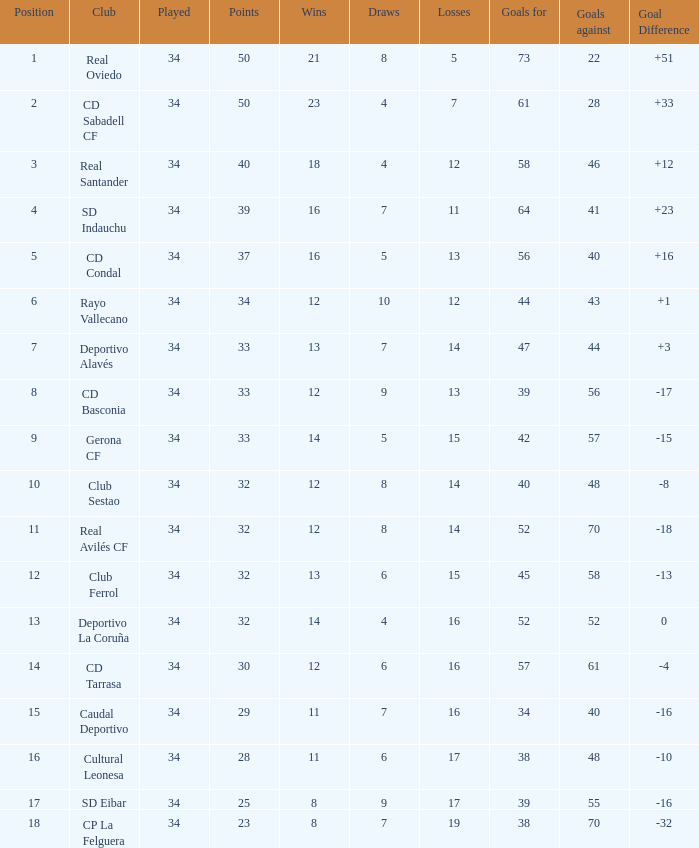Which played has draws fewer than 7, and goals for fewer than 61, and goals against fewer than 48, and a position of 5? 34.0. 